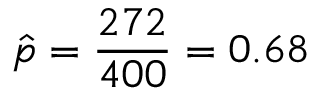Convert formula to latex. <formula><loc_0><loc_0><loc_500><loc_500>{ \hat { p } } = { \frac { 2 7 2 } { 4 0 0 } } = 0 . 6 8</formula> 